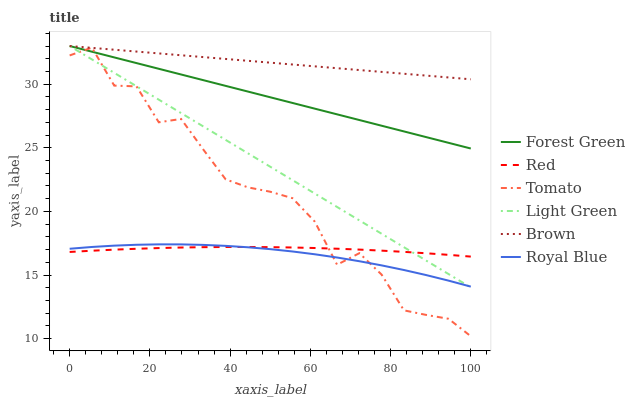Does Royal Blue have the minimum area under the curve?
Answer yes or no. Yes. Does Brown have the maximum area under the curve?
Answer yes or no. Yes. Does Brown have the minimum area under the curve?
Answer yes or no. No. Does Royal Blue have the maximum area under the curve?
Answer yes or no. No. Is Forest Green the smoothest?
Answer yes or no. Yes. Is Tomato the roughest?
Answer yes or no. Yes. Is Brown the smoothest?
Answer yes or no. No. Is Brown the roughest?
Answer yes or no. No. Does Tomato have the lowest value?
Answer yes or no. Yes. Does Royal Blue have the lowest value?
Answer yes or no. No. Does Light Green have the highest value?
Answer yes or no. Yes. Does Royal Blue have the highest value?
Answer yes or no. No. Is Red less than Brown?
Answer yes or no. Yes. Is Brown greater than Royal Blue?
Answer yes or no. Yes. Does Forest Green intersect Light Green?
Answer yes or no. Yes. Is Forest Green less than Light Green?
Answer yes or no. No. Is Forest Green greater than Light Green?
Answer yes or no. No. Does Red intersect Brown?
Answer yes or no. No. 